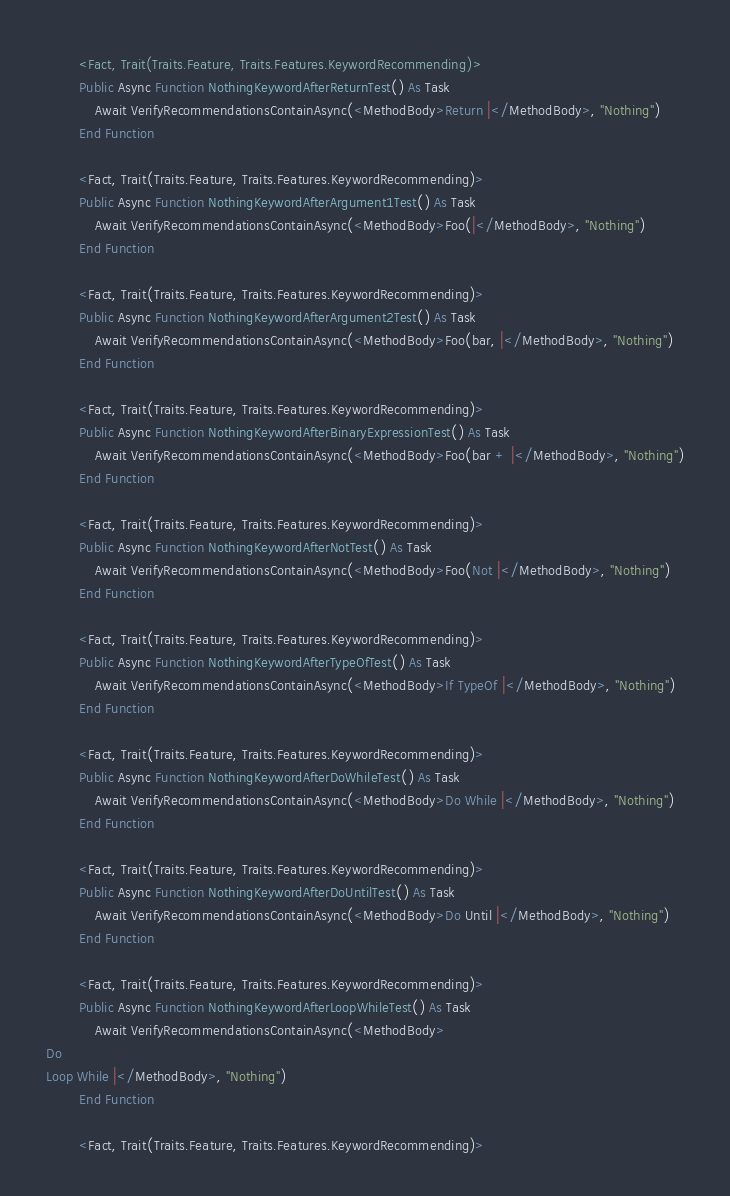<code> <loc_0><loc_0><loc_500><loc_500><_VisualBasic_>        <Fact, Trait(Traits.Feature, Traits.Features.KeywordRecommending)>
        Public Async Function NothingKeywordAfterReturnTest() As Task
            Await VerifyRecommendationsContainAsync(<MethodBody>Return |</MethodBody>, "Nothing")
        End Function

        <Fact, Trait(Traits.Feature, Traits.Features.KeywordRecommending)>
        Public Async Function NothingKeywordAfterArgument1Test() As Task
            Await VerifyRecommendationsContainAsync(<MethodBody>Foo(|</MethodBody>, "Nothing")
        End Function

        <Fact, Trait(Traits.Feature, Traits.Features.KeywordRecommending)>
        Public Async Function NothingKeywordAfterArgument2Test() As Task
            Await VerifyRecommendationsContainAsync(<MethodBody>Foo(bar, |</MethodBody>, "Nothing")
        End Function

        <Fact, Trait(Traits.Feature, Traits.Features.KeywordRecommending)>
        Public Async Function NothingKeywordAfterBinaryExpressionTest() As Task
            Await VerifyRecommendationsContainAsync(<MethodBody>Foo(bar + |</MethodBody>, "Nothing")
        End Function

        <Fact, Trait(Traits.Feature, Traits.Features.KeywordRecommending)>
        Public Async Function NothingKeywordAfterNotTest() As Task
            Await VerifyRecommendationsContainAsync(<MethodBody>Foo(Not |</MethodBody>, "Nothing")
        End Function

        <Fact, Trait(Traits.Feature, Traits.Features.KeywordRecommending)>
        Public Async Function NothingKeywordAfterTypeOfTest() As Task
            Await VerifyRecommendationsContainAsync(<MethodBody>If TypeOf |</MethodBody>, "Nothing")
        End Function

        <Fact, Trait(Traits.Feature, Traits.Features.KeywordRecommending)>
        Public Async Function NothingKeywordAfterDoWhileTest() As Task
            Await VerifyRecommendationsContainAsync(<MethodBody>Do While |</MethodBody>, "Nothing")
        End Function

        <Fact, Trait(Traits.Feature, Traits.Features.KeywordRecommending)>
        Public Async Function NothingKeywordAfterDoUntilTest() As Task
            Await VerifyRecommendationsContainAsync(<MethodBody>Do Until |</MethodBody>, "Nothing")
        End Function

        <Fact, Trait(Traits.Feature, Traits.Features.KeywordRecommending)>
        Public Async Function NothingKeywordAfterLoopWhileTest() As Task
            Await VerifyRecommendationsContainAsync(<MethodBody>
Do
Loop While |</MethodBody>, "Nothing")
        End Function

        <Fact, Trait(Traits.Feature, Traits.Features.KeywordRecommending)></code> 